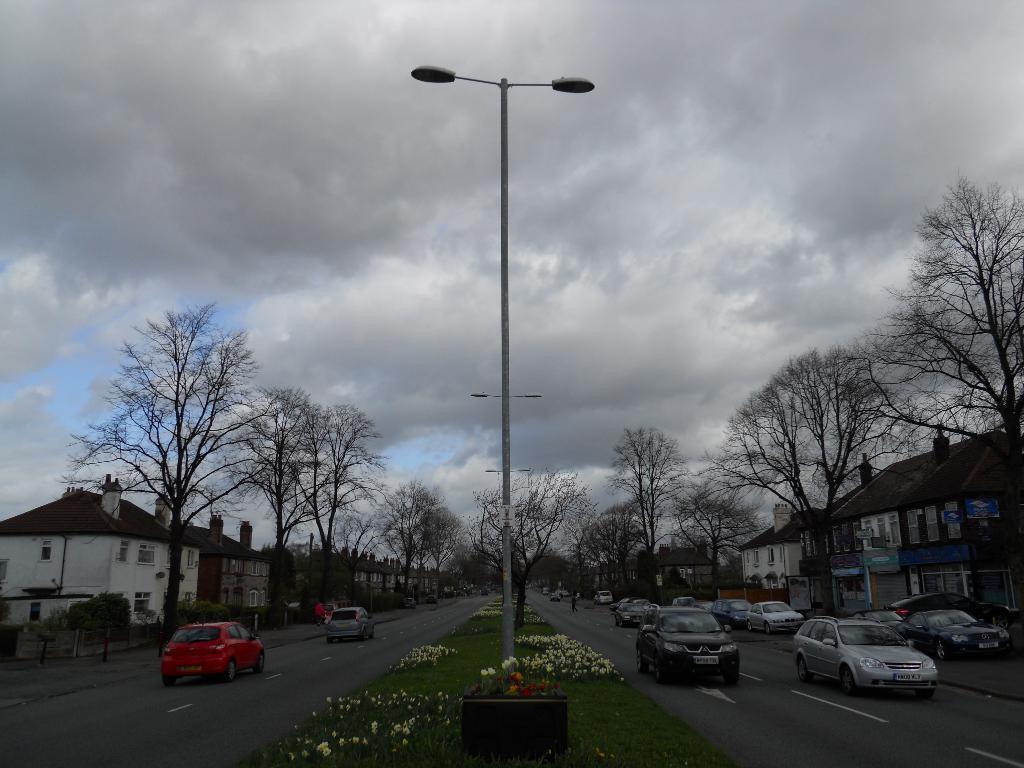Describe this image in one or two sentences. In this image, in the middle, we can see a street light, plants with some flowers and a grass. On the right side, we can see few vehicles which are moving on the road, building, trees. On the left side, we can also see some vehicles which are moving on the road, trees, plants, building, window. At the top, we can see a sky which is cloudy, at the bottom, we can see a road and a grass. 